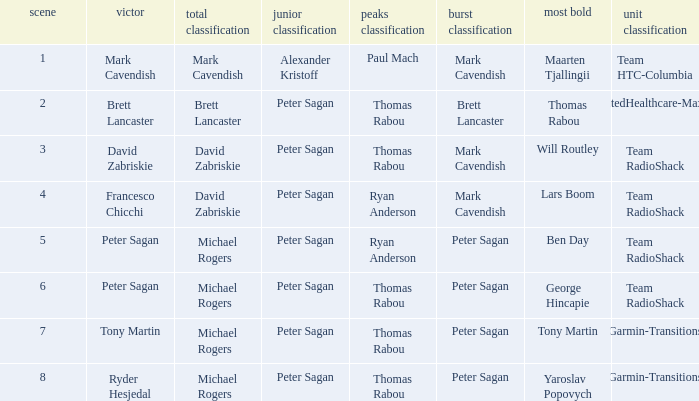When Brett Lancaster won the general classification, who won the team calssification? UnitedHealthcare-Maxxis. 